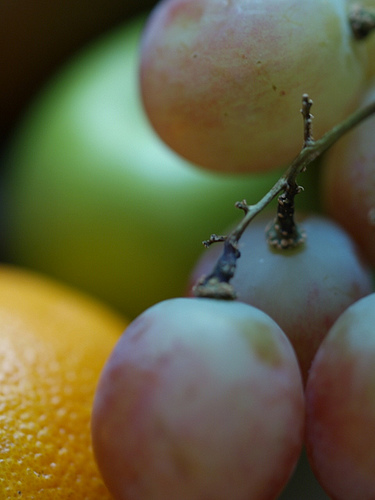<image>
Is there a fruit to the right of the fruit? Yes. From this viewpoint, the fruit is positioned to the right side relative to the fruit. 